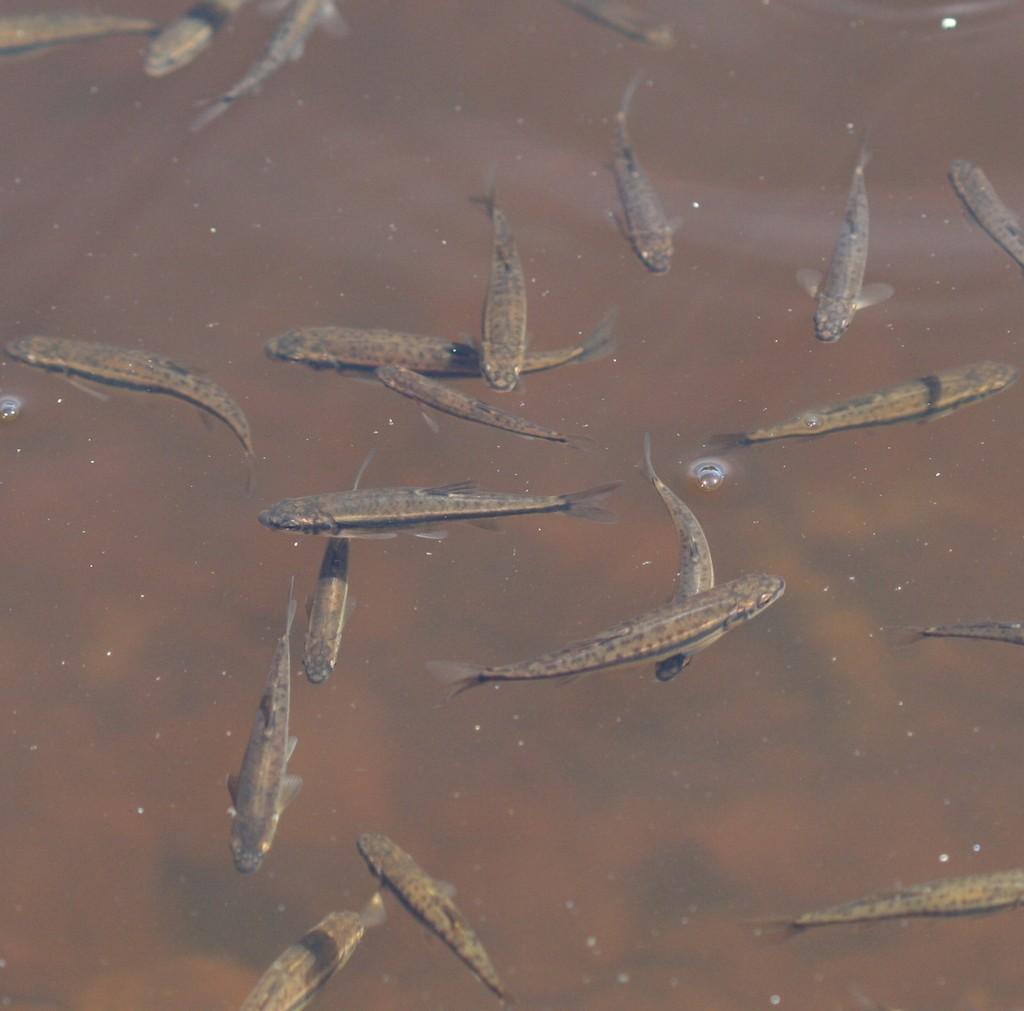In one or two sentences, can you explain what this image depicts? In this image there are fishes in the water. 